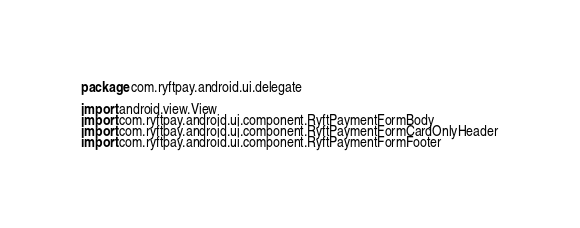Convert code to text. <code><loc_0><loc_0><loc_500><loc_500><_Kotlin_>package com.ryftpay.android.ui.delegate

import android.view.View
import com.ryftpay.android.ui.component.RyftPaymentFormBody
import com.ryftpay.android.ui.component.RyftPaymentFormCardOnlyHeader
import com.ryftpay.android.ui.component.RyftPaymentFormFooter</code> 